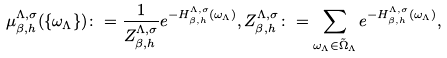Convert formula to latex. <formula><loc_0><loc_0><loc_500><loc_500>\mu _ { \beta , h } ^ { \Lambda , \sigma } ( \{ \omega _ { \Lambda } \} ) \colon = \frac { 1 } { Z _ { \beta , h } ^ { \Lambda , \sigma } } e ^ { - H _ { \beta , h } ^ { \Lambda , \sigma } ( \omega _ { \Lambda } ) } , Z _ { \beta , h } ^ { \Lambda , \sigma } \colon = \sum _ { \omega _ { \Lambda } \in \tilde { \Omega } _ { \Lambda } } e ^ { - H _ { \beta , h } ^ { \Lambda , \sigma } ( \omega _ { \Lambda } ) } ,</formula> 